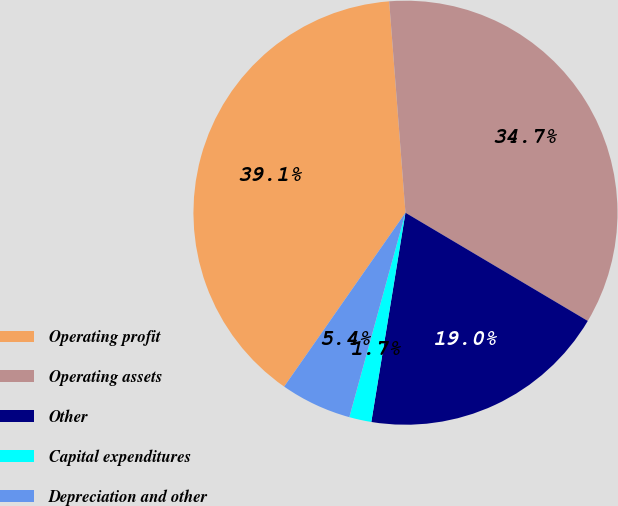<chart> <loc_0><loc_0><loc_500><loc_500><pie_chart><fcel>Operating profit<fcel>Operating assets<fcel>Other<fcel>Capital expenditures<fcel>Depreciation and other<nl><fcel>39.08%<fcel>34.75%<fcel>19.05%<fcel>1.69%<fcel>5.43%<nl></chart> 